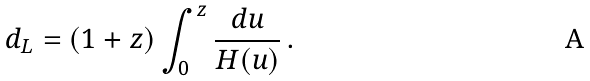Convert formula to latex. <formula><loc_0><loc_0><loc_500><loc_500>d _ { L } = ( 1 + z ) \int _ { 0 } ^ { z } \frac { d u } { H ( u ) } \, .</formula> 